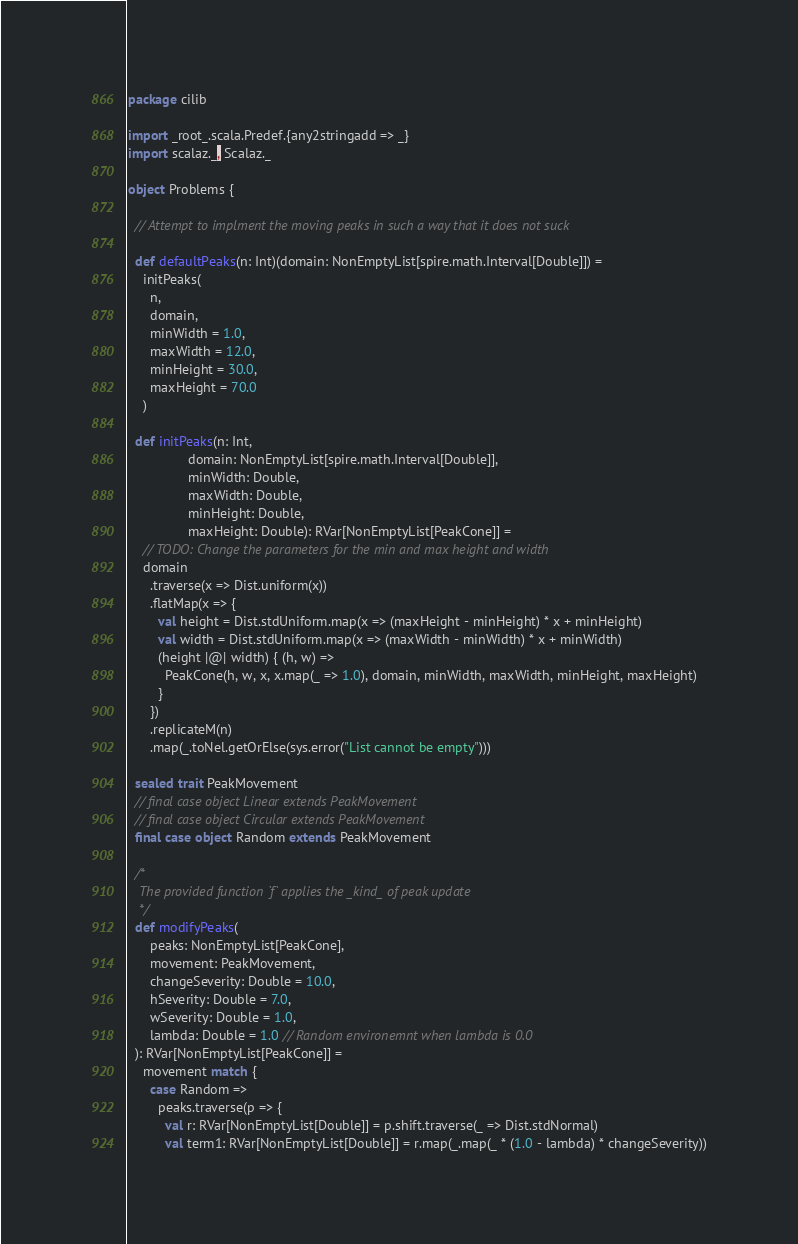<code> <loc_0><loc_0><loc_500><loc_500><_Scala_>package cilib

import _root_.scala.Predef.{any2stringadd => _}
import scalaz._, Scalaz._

object Problems {

  // Attempt to implment the moving peaks in such a way that it does not suck

  def defaultPeaks(n: Int)(domain: NonEmptyList[spire.math.Interval[Double]]) =
    initPeaks(
      n,
      domain,
      minWidth = 1.0,
      maxWidth = 12.0,
      minHeight = 30.0,
      maxHeight = 70.0
    )

  def initPeaks(n: Int,
                domain: NonEmptyList[spire.math.Interval[Double]],
                minWidth: Double,
                maxWidth: Double,
                minHeight: Double,
                maxHeight: Double): RVar[NonEmptyList[PeakCone]] =
    // TODO: Change the parameters for the min and max height and width
    domain
      .traverse(x => Dist.uniform(x))
      .flatMap(x => {
        val height = Dist.stdUniform.map(x => (maxHeight - minHeight) * x + minHeight)
        val width = Dist.stdUniform.map(x => (maxWidth - minWidth) * x + minWidth)
        (height |@| width) { (h, w) =>
          PeakCone(h, w, x, x.map(_ => 1.0), domain, minWidth, maxWidth, minHeight, maxHeight)
        }
      })
      .replicateM(n)
      .map(_.toNel.getOrElse(sys.error("List cannot be empty")))

  sealed trait PeakMovement
  // final case object Linear extends PeakMovement
  // final case object Circular extends PeakMovement
  final case object Random extends PeakMovement

  /*
   The provided function `f` applies the _kind_ of peak update
   */
  def modifyPeaks(
      peaks: NonEmptyList[PeakCone],
      movement: PeakMovement,
      changeSeverity: Double = 10.0,
      hSeverity: Double = 7.0,
      wSeverity: Double = 1.0,
      lambda: Double = 1.0 // Random environemnt when lambda is 0.0
  ): RVar[NonEmptyList[PeakCone]] =
    movement match {
      case Random =>
        peaks.traverse(p => {
          val r: RVar[NonEmptyList[Double]] = p.shift.traverse(_ => Dist.stdNormal)
          val term1: RVar[NonEmptyList[Double]] = r.map(_.map(_ * (1.0 - lambda) * changeSeverity))</code> 